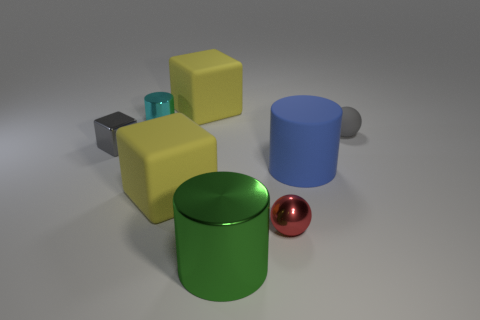Subtract all large cylinders. How many cylinders are left? 1 Subtract all blue cylinders. How many yellow blocks are left? 2 Subtract 1 blocks. How many blocks are left? 2 Add 1 red metallic spheres. How many objects exist? 9 Subtract all purple cylinders. Subtract all red cubes. How many cylinders are left? 3 Subtract all blocks. How many objects are left? 5 Subtract 0 purple cylinders. How many objects are left? 8 Subtract all small blue cylinders. Subtract all yellow matte cubes. How many objects are left? 6 Add 7 large yellow blocks. How many large yellow blocks are left? 9 Add 2 large yellow matte cylinders. How many large yellow matte cylinders exist? 2 